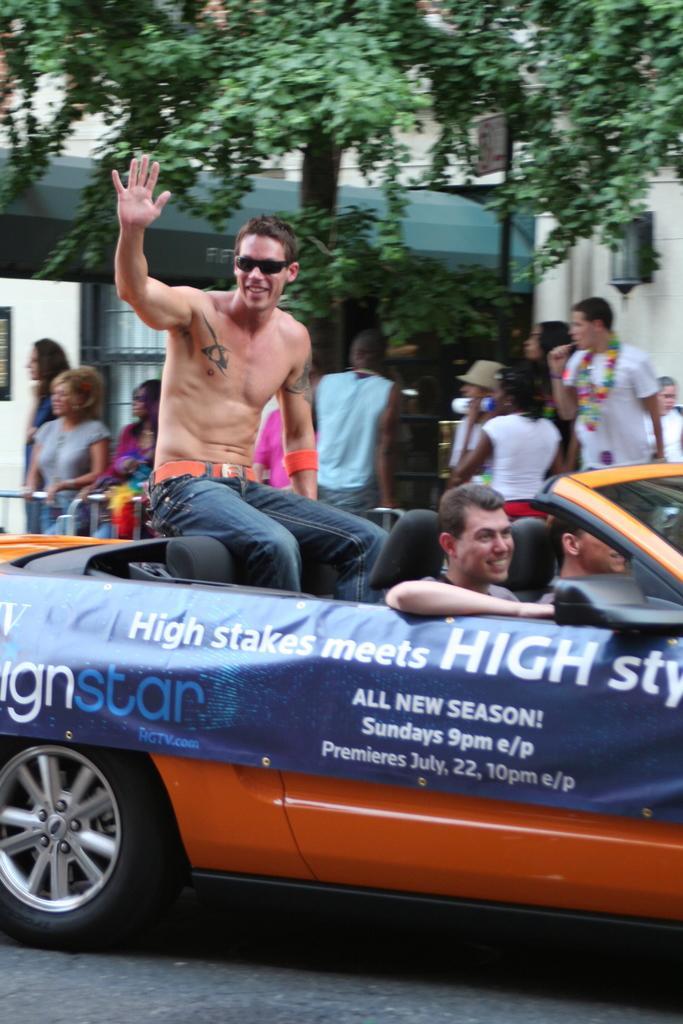How would you summarize this image in a sentence or two? In this image there is a man who is sitting in the car and two persons in the car who are driving in the road and at the back ground there are some group of people who are standing and at the right side there are some people who are standing and there is a sign board with the pole , tree and a building. 